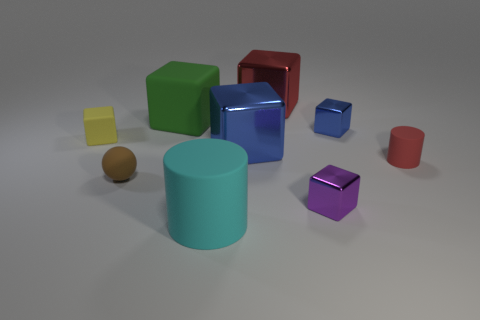Can you tell if the objects are arranged in any particular pattern? The objects do not seem to be arranged in a specific pattern; their placement appears somewhat random. However, they are spaced out in a manner that doesn't suggest any intentional formation or symmetry. 